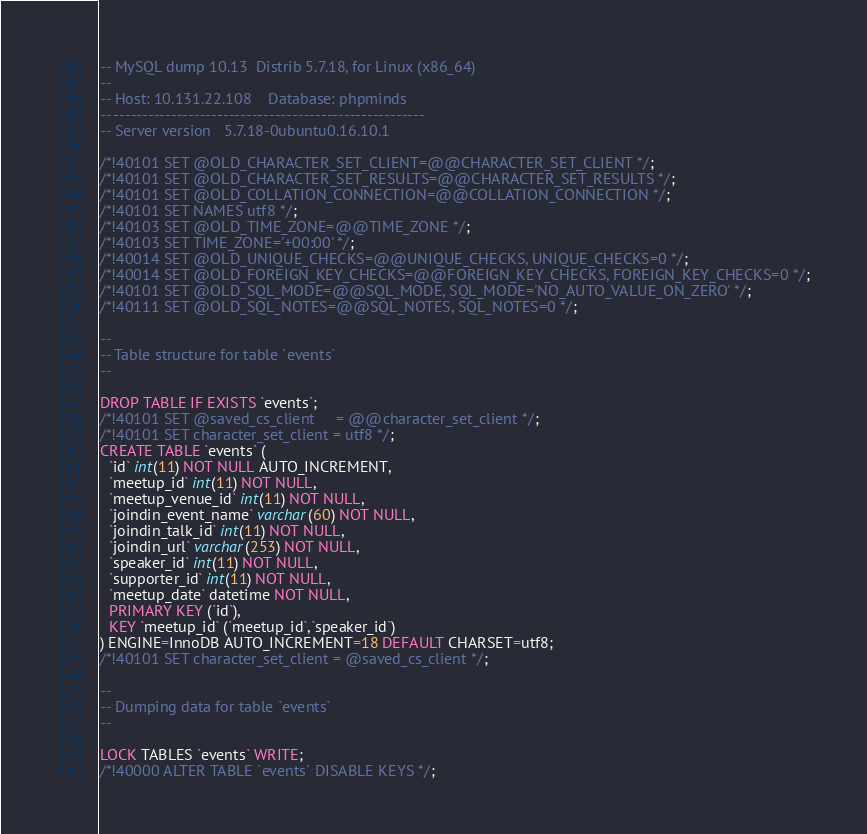Convert code to text. <code><loc_0><loc_0><loc_500><loc_500><_SQL_>-- MySQL dump 10.13  Distrib 5.7.18, for Linux (x86_64)
--
-- Host: 10.131.22.108    Database: phpminds
-- ------------------------------------------------------
-- Server version	5.7.18-0ubuntu0.16.10.1

/*!40101 SET @OLD_CHARACTER_SET_CLIENT=@@CHARACTER_SET_CLIENT */;
/*!40101 SET @OLD_CHARACTER_SET_RESULTS=@@CHARACTER_SET_RESULTS */;
/*!40101 SET @OLD_COLLATION_CONNECTION=@@COLLATION_CONNECTION */;
/*!40101 SET NAMES utf8 */;
/*!40103 SET @OLD_TIME_ZONE=@@TIME_ZONE */;
/*!40103 SET TIME_ZONE='+00:00' */;
/*!40014 SET @OLD_UNIQUE_CHECKS=@@UNIQUE_CHECKS, UNIQUE_CHECKS=0 */;
/*!40014 SET @OLD_FOREIGN_KEY_CHECKS=@@FOREIGN_KEY_CHECKS, FOREIGN_KEY_CHECKS=0 */;
/*!40101 SET @OLD_SQL_MODE=@@SQL_MODE, SQL_MODE='NO_AUTO_VALUE_ON_ZERO' */;
/*!40111 SET @OLD_SQL_NOTES=@@SQL_NOTES, SQL_NOTES=0 */;

--
-- Table structure for table `events`
--

DROP TABLE IF EXISTS `events`;
/*!40101 SET @saved_cs_client     = @@character_set_client */;
/*!40101 SET character_set_client = utf8 */;
CREATE TABLE `events` (
  `id` int(11) NOT NULL AUTO_INCREMENT,
  `meetup_id` int(11) NOT NULL,
  `meetup_venue_id` int(11) NOT NULL,
  `joindin_event_name` varchar(60) NOT NULL,
  `joindin_talk_id` int(11) NOT NULL,
  `joindin_url` varchar(253) NOT NULL,
  `speaker_id` int(11) NOT NULL,
  `supporter_id` int(11) NOT NULL,
  `meetup_date` datetime NOT NULL,
  PRIMARY KEY (`id`),
  KEY `meetup_id` (`meetup_id`,`speaker_id`)
) ENGINE=InnoDB AUTO_INCREMENT=18 DEFAULT CHARSET=utf8;
/*!40101 SET character_set_client = @saved_cs_client */;

--
-- Dumping data for table `events`
--

LOCK TABLES `events` WRITE;
/*!40000 ALTER TABLE `events` DISABLE KEYS */;</code> 